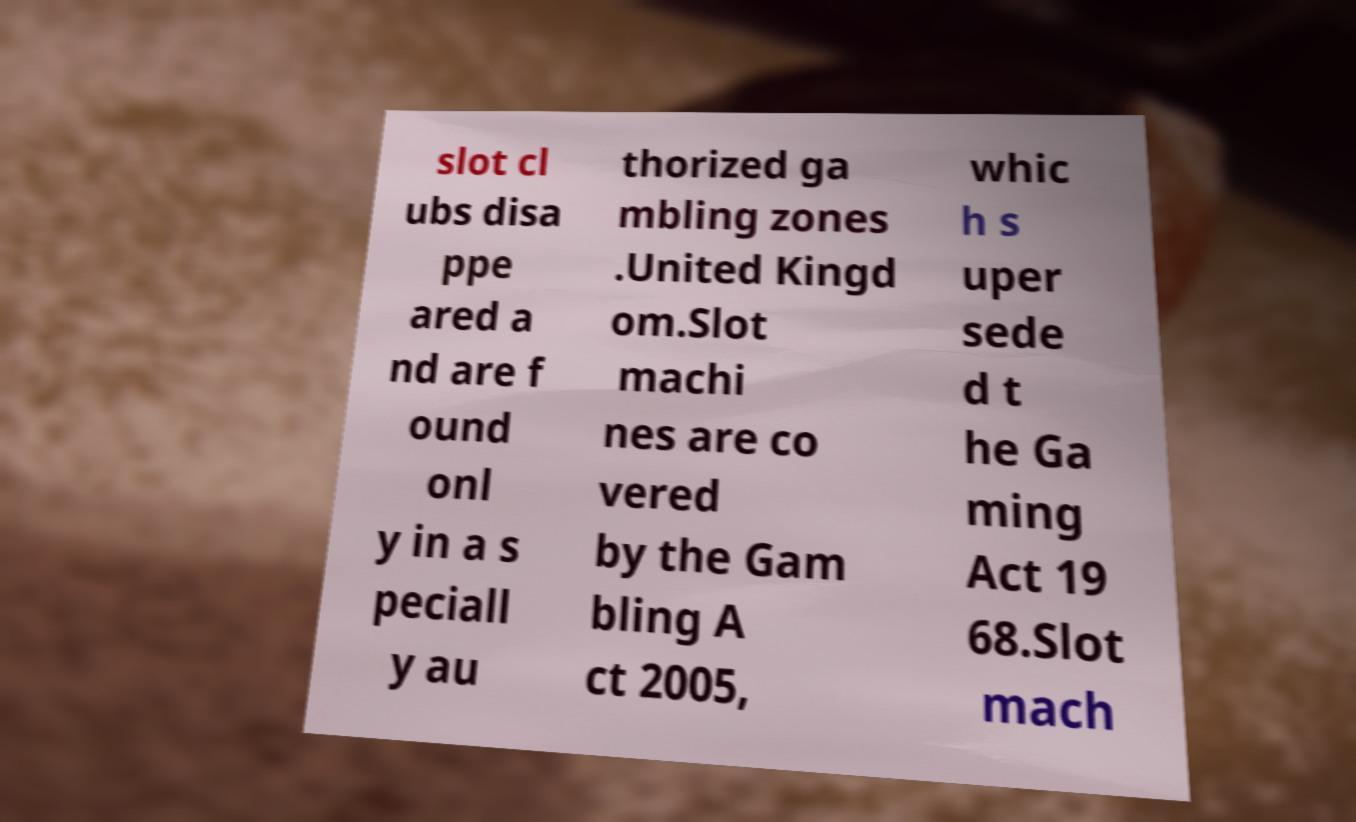Please identify and transcribe the text found in this image. slot cl ubs disa ppe ared a nd are f ound onl y in a s peciall y au thorized ga mbling zones .United Kingd om.Slot machi nes are co vered by the Gam bling A ct 2005, whic h s uper sede d t he Ga ming Act 19 68.Slot mach 